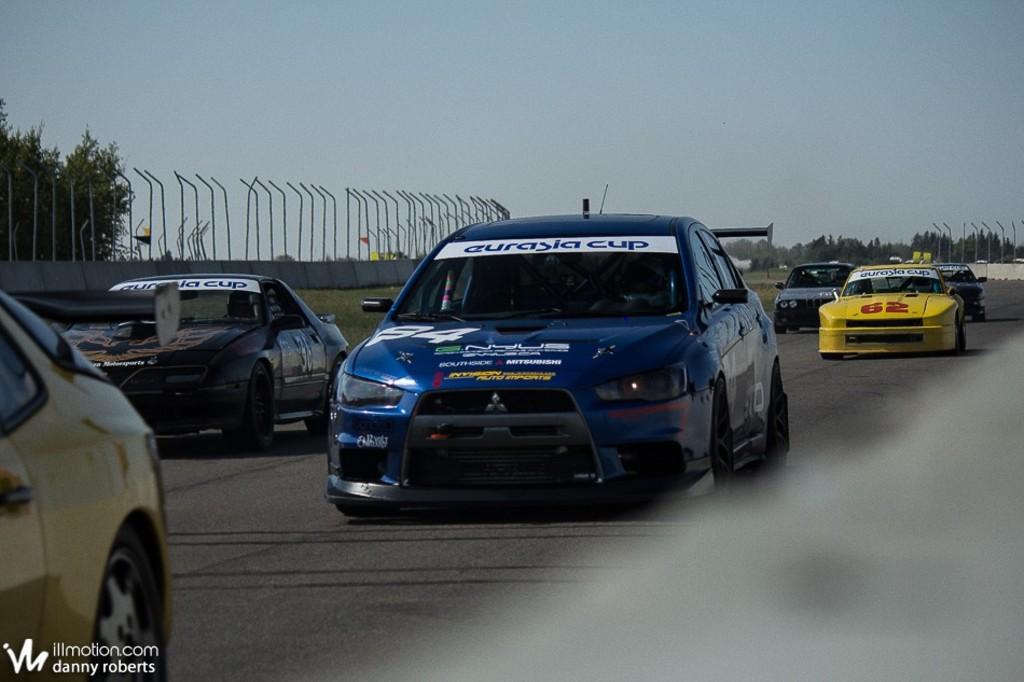Could you give a brief overview of what you see in this image? As we can see in the image there are different colors of cars, trees, wall and sky. 